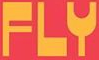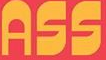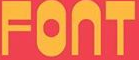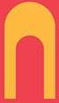Read the text content from these images in order, separated by a semicolon. FLY; ASS; FONT; N 